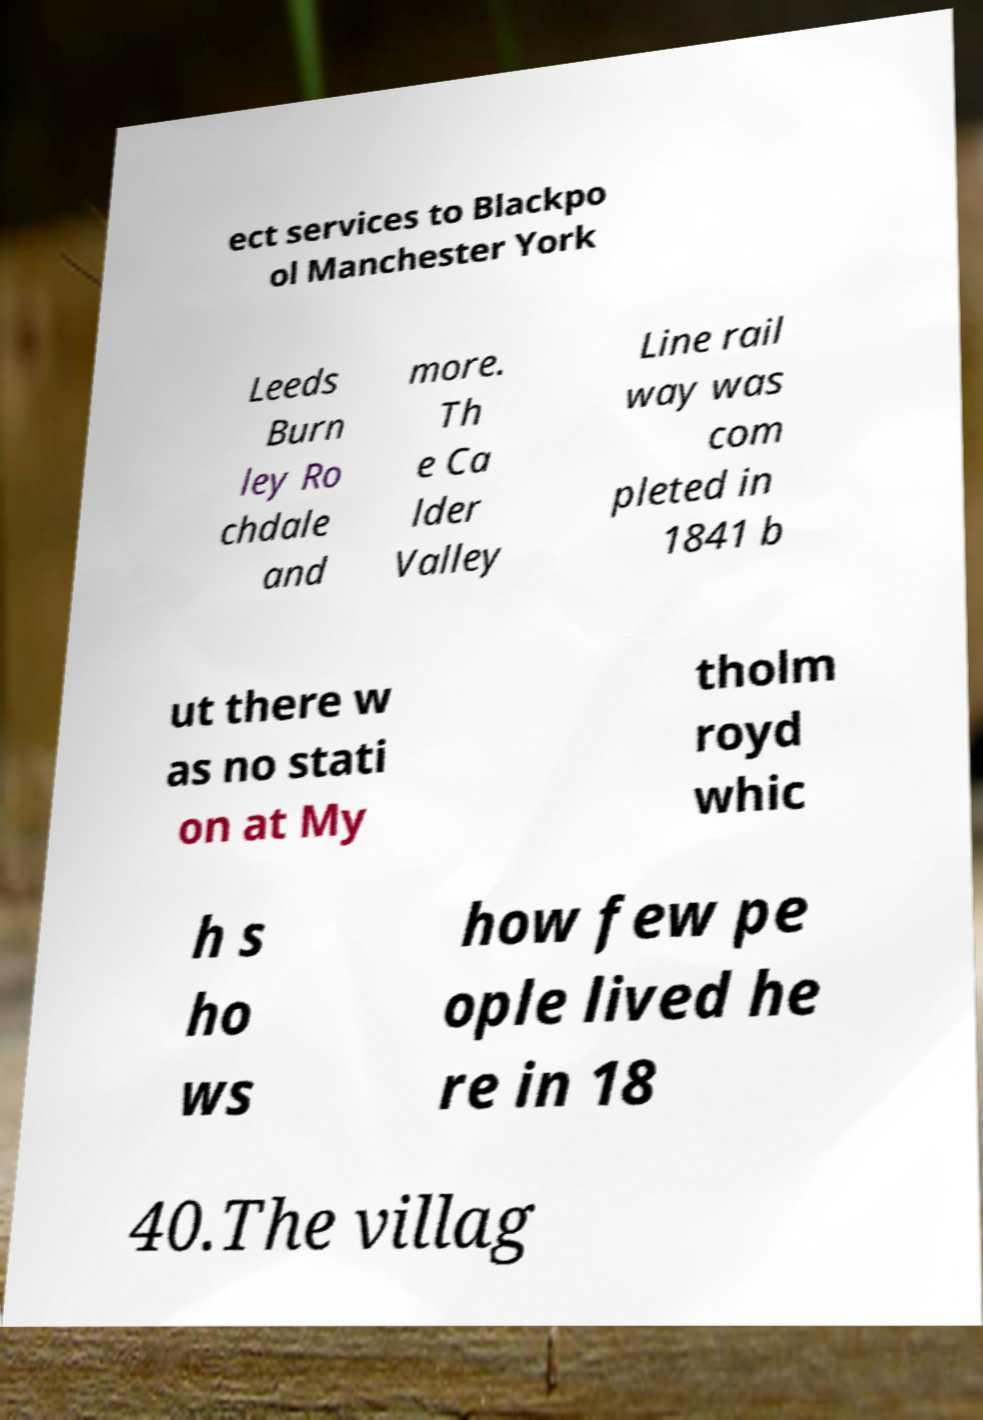Can you accurately transcribe the text from the provided image for me? ect services to Blackpo ol Manchester York Leeds Burn ley Ro chdale and more. Th e Ca lder Valley Line rail way was com pleted in 1841 b ut there w as no stati on at My tholm royd whic h s ho ws how few pe ople lived he re in 18 40.The villag 